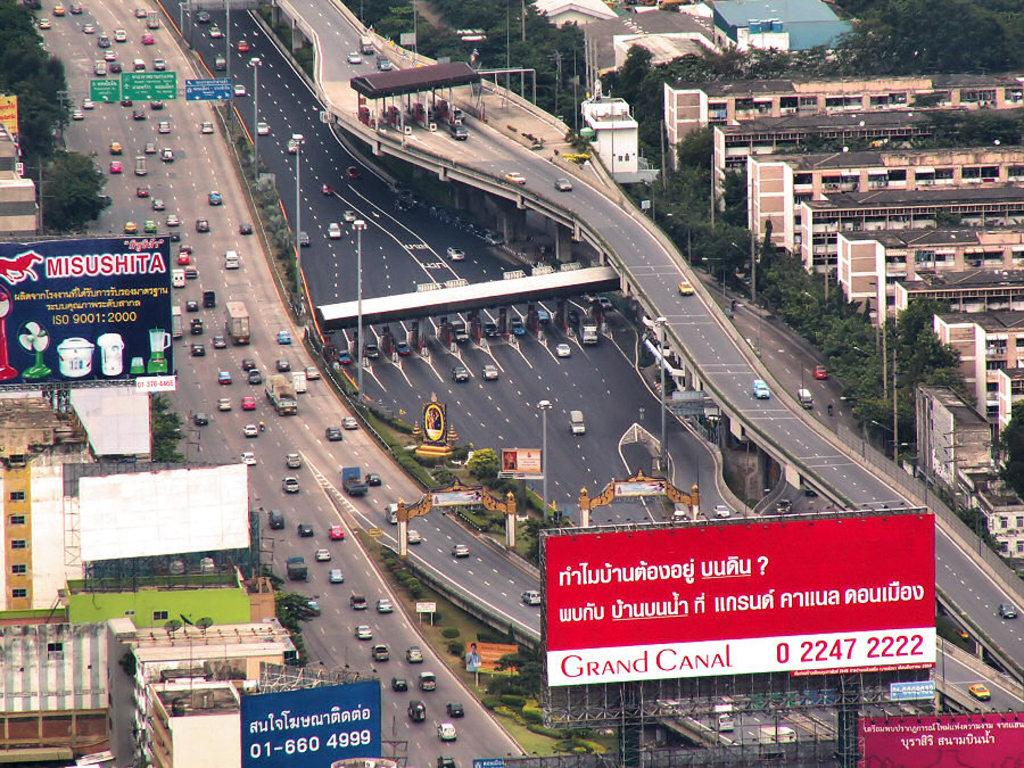<image>
Summarize the visual content of the image. An ariel view of a busy highway with billboards for Grand Canal and Misushita. 